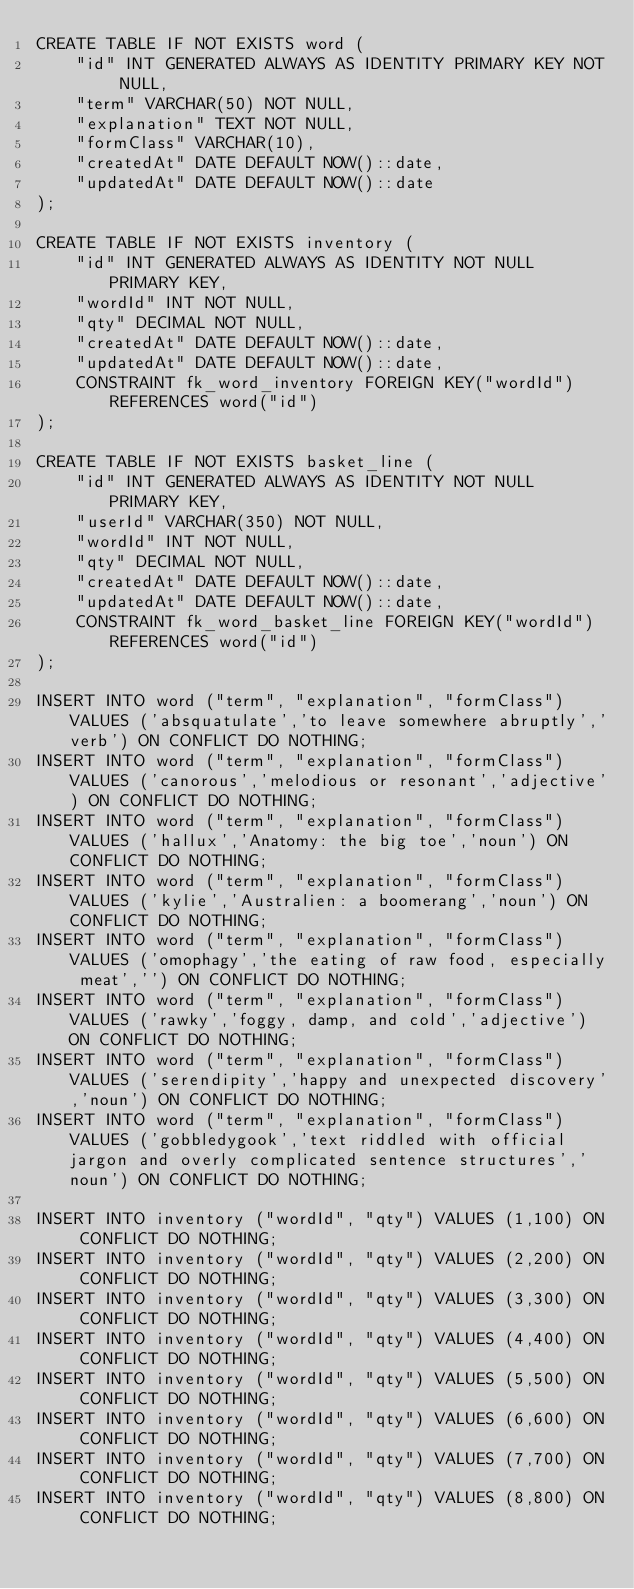<code> <loc_0><loc_0><loc_500><loc_500><_SQL_>CREATE TABLE IF NOT EXISTS word (
    "id" INT GENERATED ALWAYS AS IDENTITY PRIMARY KEY NOT NULL, 
    "term" VARCHAR(50) NOT NULL, 
    "explanation" TEXT NOT NULL,
    "formClass" VARCHAR(10),
    "createdAt" DATE DEFAULT NOW()::date,
    "updatedAt" DATE DEFAULT NOW()::date
);

CREATE TABLE IF NOT EXISTS inventory (
    "id" INT GENERATED ALWAYS AS IDENTITY NOT NULL PRIMARY KEY, 
    "wordId" INT NOT NULL, 
    "qty" DECIMAL NOT NULL,
    "createdAt" DATE DEFAULT NOW()::date,
    "updatedAt" DATE DEFAULT NOW()::date,
    CONSTRAINT fk_word_inventory FOREIGN KEY("wordId") REFERENCES word("id")
);

CREATE TABLE IF NOT EXISTS basket_line (
    "id" INT GENERATED ALWAYS AS IDENTITY NOT NULL PRIMARY KEY,
    "userId" VARCHAR(350) NOT NULL, 
    "wordId" INT NOT NULL, 
    "qty" DECIMAL NOT NULL,
    "createdAt" DATE DEFAULT NOW()::date,
    "updatedAt" DATE DEFAULT NOW()::date,
    CONSTRAINT fk_word_basket_line FOREIGN KEY("wordId") REFERENCES word("id")
);

INSERT INTO word ("term", "explanation", "formClass") VALUES ('absquatulate','to leave somewhere abruptly','verb') ON CONFLICT DO NOTHING;
INSERT INTO word ("term", "explanation", "formClass") VALUES ('canorous','melodious or resonant','adjective') ON CONFLICT DO NOTHING;
INSERT INTO word ("term", "explanation", "formClass") VALUES ('hallux','Anatomy: the big toe','noun') ON CONFLICT DO NOTHING;
INSERT INTO word ("term", "explanation", "formClass") VALUES ('kylie','Australien: a boomerang','noun') ON CONFLICT DO NOTHING;
INSERT INTO word ("term", "explanation", "formClass") VALUES ('omophagy','the eating of raw food, especially meat','') ON CONFLICT DO NOTHING;
INSERT INTO word ("term", "explanation", "formClass") VALUES ('rawky','foggy, damp, and cold','adjective') ON CONFLICT DO NOTHING;
INSERT INTO word ("term", "explanation", "formClass") VALUES ('serendipity','happy and unexpected discovery','noun') ON CONFLICT DO NOTHING;
INSERT INTO word ("term", "explanation", "formClass") VALUES ('gobbledygook','text riddled with official jargon and overly complicated sentence structures','noun') ON CONFLICT DO NOTHING;

INSERT INTO inventory ("wordId", "qty") VALUES (1,100) ON CONFLICT DO NOTHING;
INSERT INTO inventory ("wordId", "qty") VALUES (2,200) ON CONFLICT DO NOTHING;
INSERT INTO inventory ("wordId", "qty") VALUES (3,300) ON CONFLICT DO NOTHING;
INSERT INTO inventory ("wordId", "qty") VALUES (4,400) ON CONFLICT DO NOTHING;
INSERT INTO inventory ("wordId", "qty") VALUES (5,500) ON CONFLICT DO NOTHING;
INSERT INTO inventory ("wordId", "qty") VALUES (6,600) ON CONFLICT DO NOTHING;
INSERT INTO inventory ("wordId", "qty") VALUES (7,700) ON CONFLICT DO NOTHING;
INSERT INTO inventory ("wordId", "qty") VALUES (8,800) ON CONFLICT DO NOTHING;
</code> 